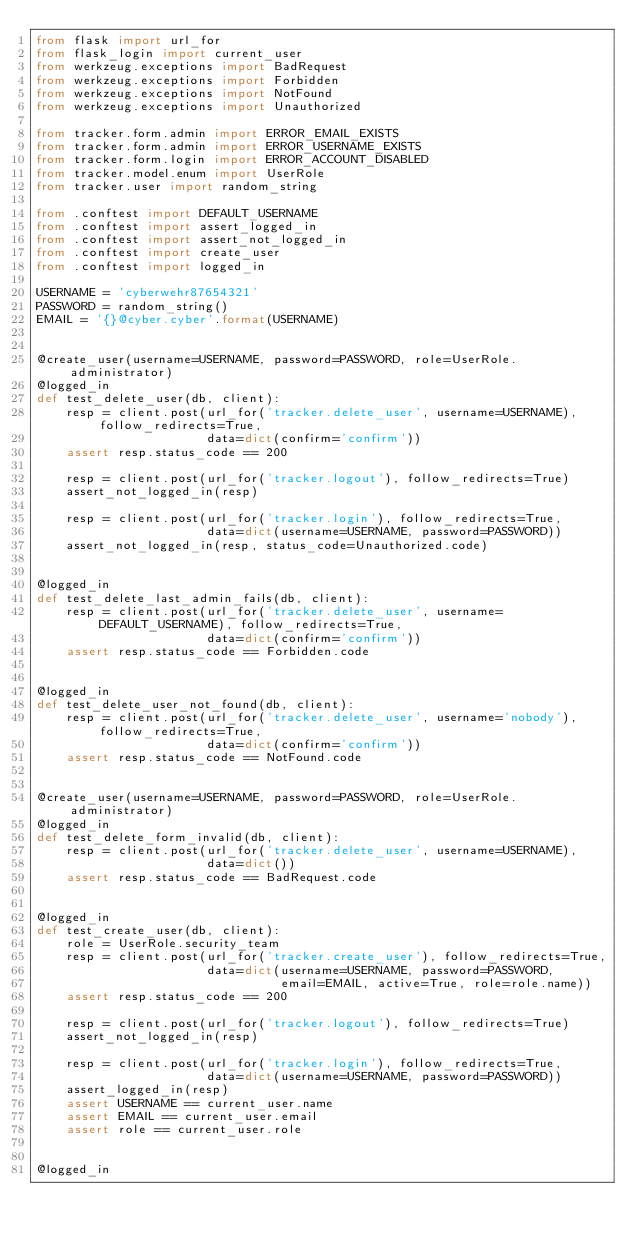<code> <loc_0><loc_0><loc_500><loc_500><_Python_>from flask import url_for
from flask_login import current_user
from werkzeug.exceptions import BadRequest
from werkzeug.exceptions import Forbidden
from werkzeug.exceptions import NotFound
from werkzeug.exceptions import Unauthorized

from tracker.form.admin import ERROR_EMAIL_EXISTS
from tracker.form.admin import ERROR_USERNAME_EXISTS
from tracker.form.login import ERROR_ACCOUNT_DISABLED
from tracker.model.enum import UserRole
from tracker.user import random_string

from .conftest import DEFAULT_USERNAME
from .conftest import assert_logged_in
from .conftest import assert_not_logged_in
from .conftest import create_user
from .conftest import logged_in

USERNAME = 'cyberwehr87654321'
PASSWORD = random_string()
EMAIL = '{}@cyber.cyber'.format(USERNAME)


@create_user(username=USERNAME, password=PASSWORD, role=UserRole.administrator)
@logged_in
def test_delete_user(db, client):
    resp = client.post(url_for('tracker.delete_user', username=USERNAME), follow_redirects=True,
                       data=dict(confirm='confirm'))
    assert resp.status_code == 200

    resp = client.post(url_for('tracker.logout'), follow_redirects=True)
    assert_not_logged_in(resp)

    resp = client.post(url_for('tracker.login'), follow_redirects=True,
                       data=dict(username=USERNAME, password=PASSWORD))
    assert_not_logged_in(resp, status_code=Unauthorized.code)


@logged_in
def test_delete_last_admin_fails(db, client):
    resp = client.post(url_for('tracker.delete_user', username=DEFAULT_USERNAME), follow_redirects=True,
                       data=dict(confirm='confirm'))
    assert resp.status_code == Forbidden.code


@logged_in
def test_delete_user_not_found(db, client):
    resp = client.post(url_for('tracker.delete_user', username='nobody'), follow_redirects=True,
                       data=dict(confirm='confirm'))
    assert resp.status_code == NotFound.code


@create_user(username=USERNAME, password=PASSWORD, role=UserRole.administrator)
@logged_in
def test_delete_form_invalid(db, client):
    resp = client.post(url_for('tracker.delete_user', username=USERNAME),
                       data=dict())
    assert resp.status_code == BadRequest.code


@logged_in
def test_create_user(db, client):
    role = UserRole.security_team
    resp = client.post(url_for('tracker.create_user'), follow_redirects=True,
                       data=dict(username=USERNAME, password=PASSWORD,
                                 email=EMAIL, active=True, role=role.name))
    assert resp.status_code == 200

    resp = client.post(url_for('tracker.logout'), follow_redirects=True)
    assert_not_logged_in(resp)

    resp = client.post(url_for('tracker.login'), follow_redirects=True,
                       data=dict(username=USERNAME, password=PASSWORD))
    assert_logged_in(resp)
    assert USERNAME == current_user.name
    assert EMAIL == current_user.email
    assert role == current_user.role


@logged_in</code> 